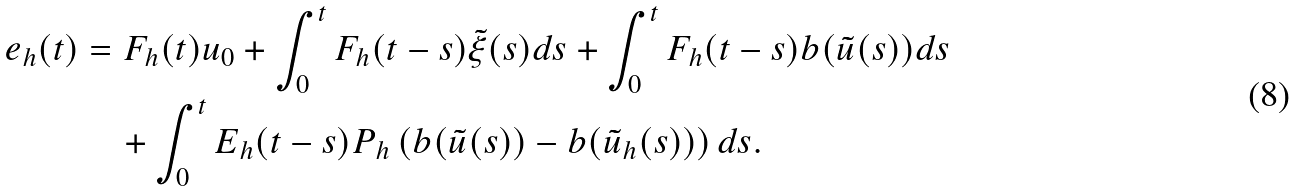Convert formula to latex. <formula><loc_0><loc_0><loc_500><loc_500>e _ { h } ( t ) & = F _ { h } ( t ) u _ { 0 } + \int _ { 0 } ^ { t } F _ { h } ( t - s ) \tilde { \xi } ( s ) d s + \int _ { 0 } ^ { t } F _ { h } ( t - s ) b ( \tilde { u } ( s ) ) d s \\ & \quad + \int _ { 0 } ^ { t } E _ { h } ( t - s ) P _ { h } \left ( b ( \tilde { u } ( s ) ) - b ( \tilde { u } _ { h } ( s ) ) \right ) d s .</formula> 